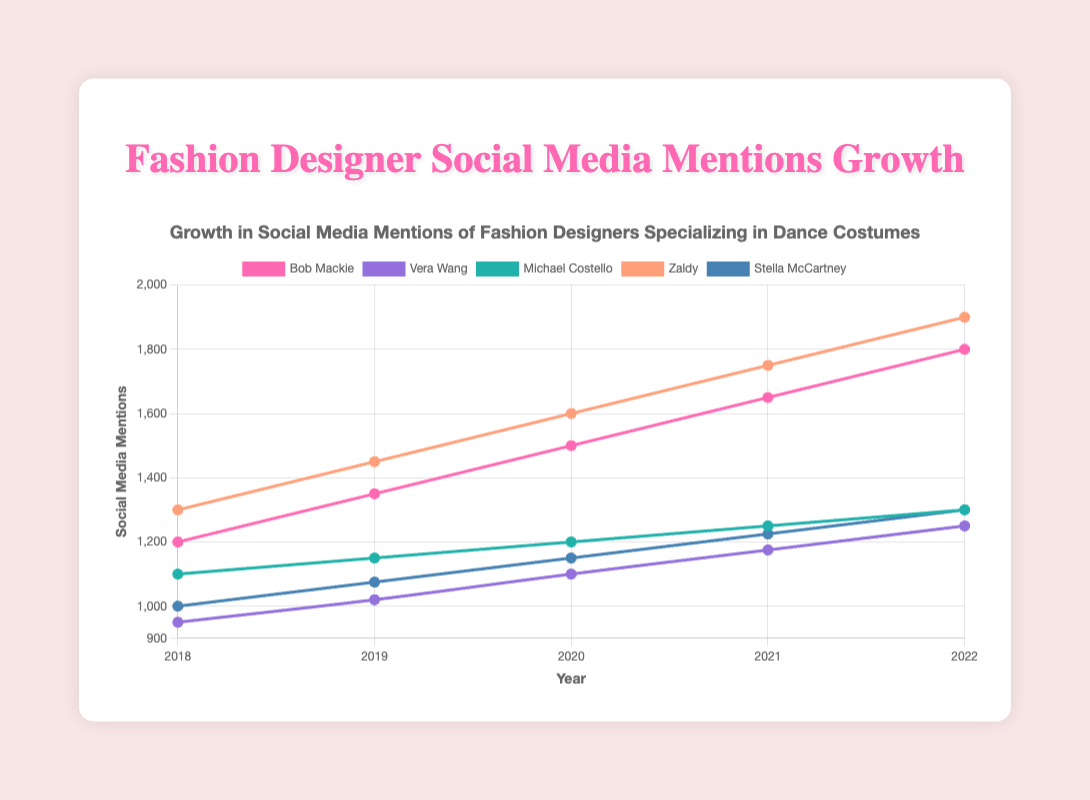Which designer had the highest number of social media mentions in 2022? In 2022, Zaldy had 1900 social media mentions, which is the highest among all the designers.
Answer: Zaldy How did Bob Mackie's social media mentions grow from 2018 to 2022? In 2018, Bob Mackie had 1200 mentions, and in 2022, he had 1800 mentions. The growth can be calculated as 1800 - 1200 = 600 mentions.
Answer: 600 Which designer had the slowest growth in social media mentions from 2018 to 2022? By examining the difference in mentions from 2018 to 2022 for each designer: Bob Mackie (600), Vera Wang (300), Michael Costello (200), Zaldy (600), and Stella McCartney (300), Michael Costello had the slowest growth with only 200 mentions.
Answer: Michael Costello Between 2020 and 2021, which designer had the largest increase in social media mentions? Zaldy had 1600 mentions in 2020 and 1750 mentions in 2021, making the increase 1750 - 1600 = 150 mentions, the largest increase in that period.
Answer: Zaldy What's the average number of social media mentions for Stella McCartney over the 5-year period? Sum of mentions of Stella McCartney over the years (1000+1075+1150+1225+1300) = 5750. Dividing by 5 years, the average is 5750 / 5 = 1150.
Answer: 1150 Comparing the growth rates, which designer's mentions increased more, Stella McCartney or Vera Wang, from 2018 to 2022? Growth for Stella McCartney: 1300 - 1000 = 300 mentions. Growth for Vera Wang: 1250 - 950 = 300 mentions. Both designers had the same growth rate of 300 mentions.
Answer: Both What year did Vera Wang surpass 1000 social media mentions? By observing the data, Vera Wang had 950 mentions in 2018 and 1020 in 2019, so she surpassed 1000 mentions in 2019.
Answer: 2019 Which designer had the highest number of social media mentions in 2019? In 2019, Zaldy had 1450 social media mentions, which is the highest among all the designers.
Answer: Zaldy How many more social media mentions did Bob Mackie have compared to Michael Costello in 2022? In 2022, Bob Mackie had 1800 mentions and Michael Costello had 1300 mentions. The difference is 1800 - 1300 = 500 mentions.
Answer: 500 Comparing the years, which year did Zaldy experience the highest increase in social media mentions? By examining the year-on-year increase for Zaldy: 2018-2019 (1450-1300=150), 2019-2020 (1600-1450=150), 2020-2021 (1750-1600=150), and 2021-2022 (1900-1750=150), Zaldy experienced a constant increase of 150 mentions each year, so there's no single year with the highest increase.
Answer: No single year 